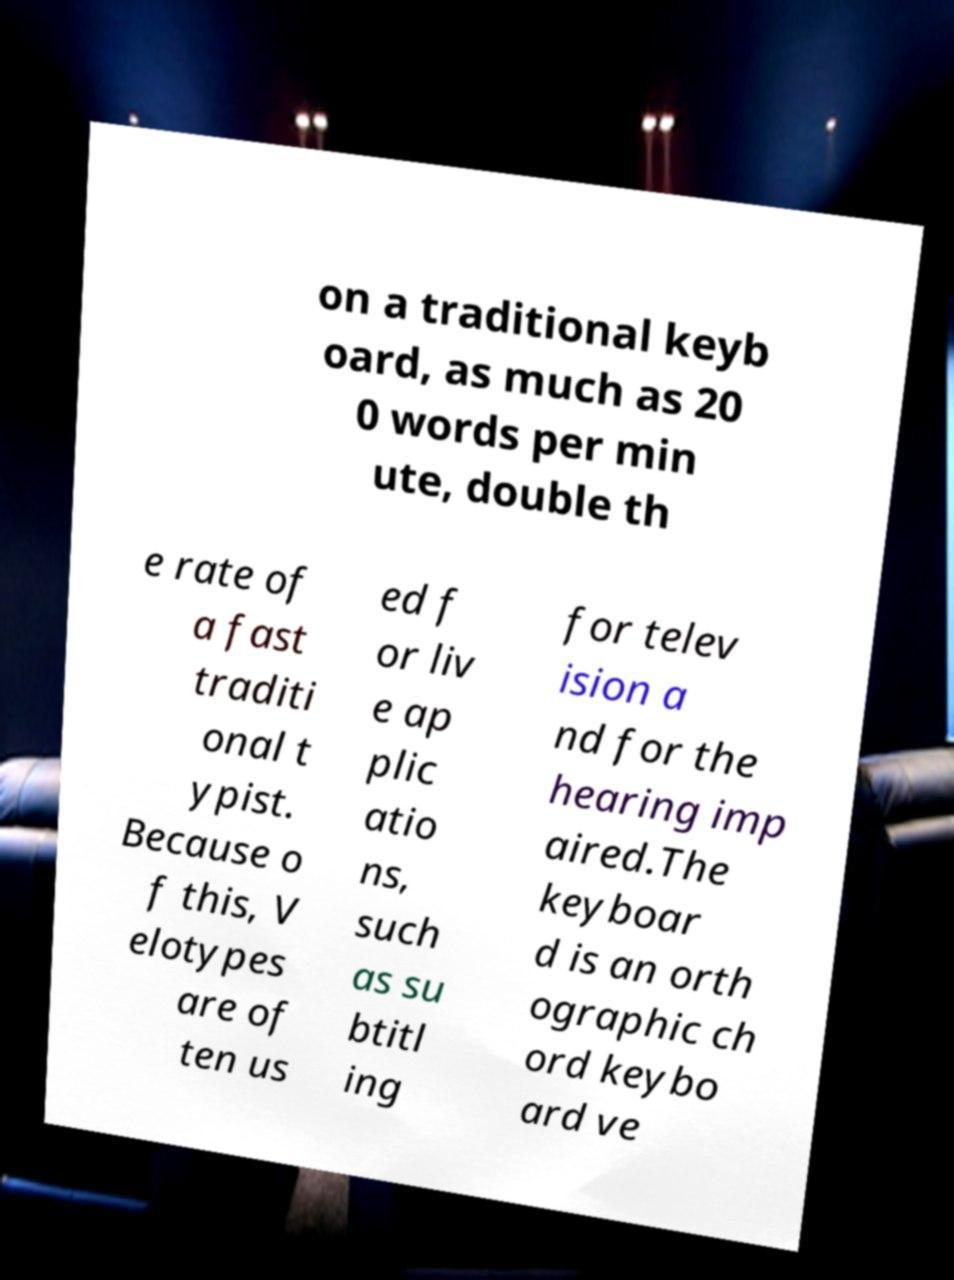There's text embedded in this image that I need extracted. Can you transcribe it verbatim? on a traditional keyb oard, as much as 20 0 words per min ute, double th e rate of a fast traditi onal t ypist. Because o f this, V elotypes are of ten us ed f or liv e ap plic atio ns, such as su btitl ing for telev ision a nd for the hearing imp aired.The keyboar d is an orth ographic ch ord keybo ard ve 